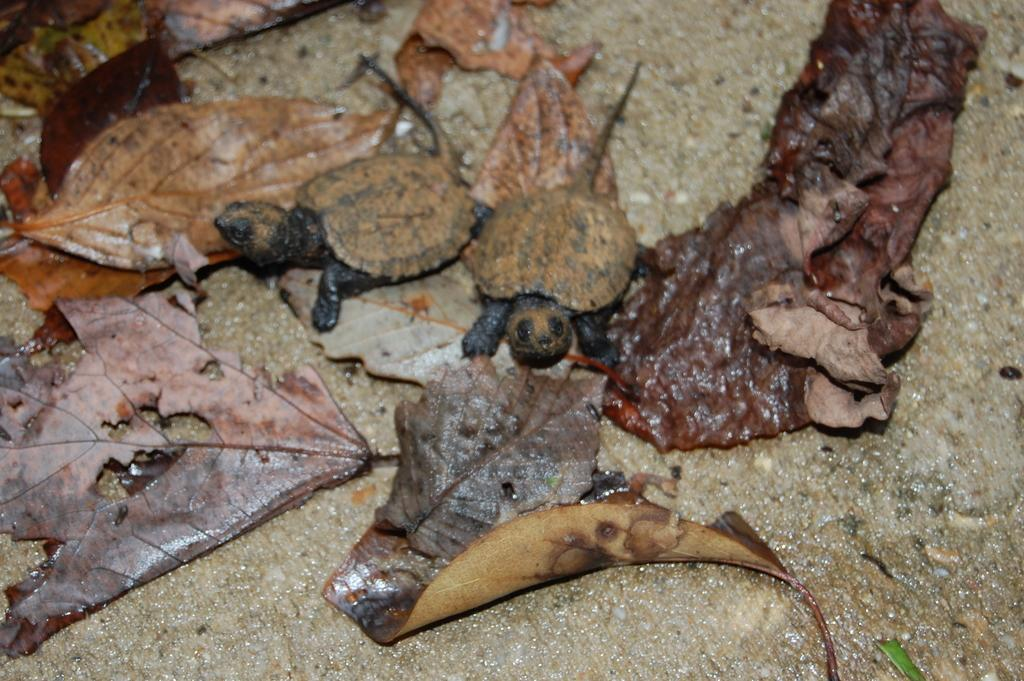What animals can be seen in the foreground of the image? There are two turtles in the foreground of the image. What can be found on the ground in the image? There are leafs on the ground in the image. What type of rhythm can be heard coming from the turtles in the image? There is no sound or rhythm associated with the turtles in the image; they are stationary and silent. 